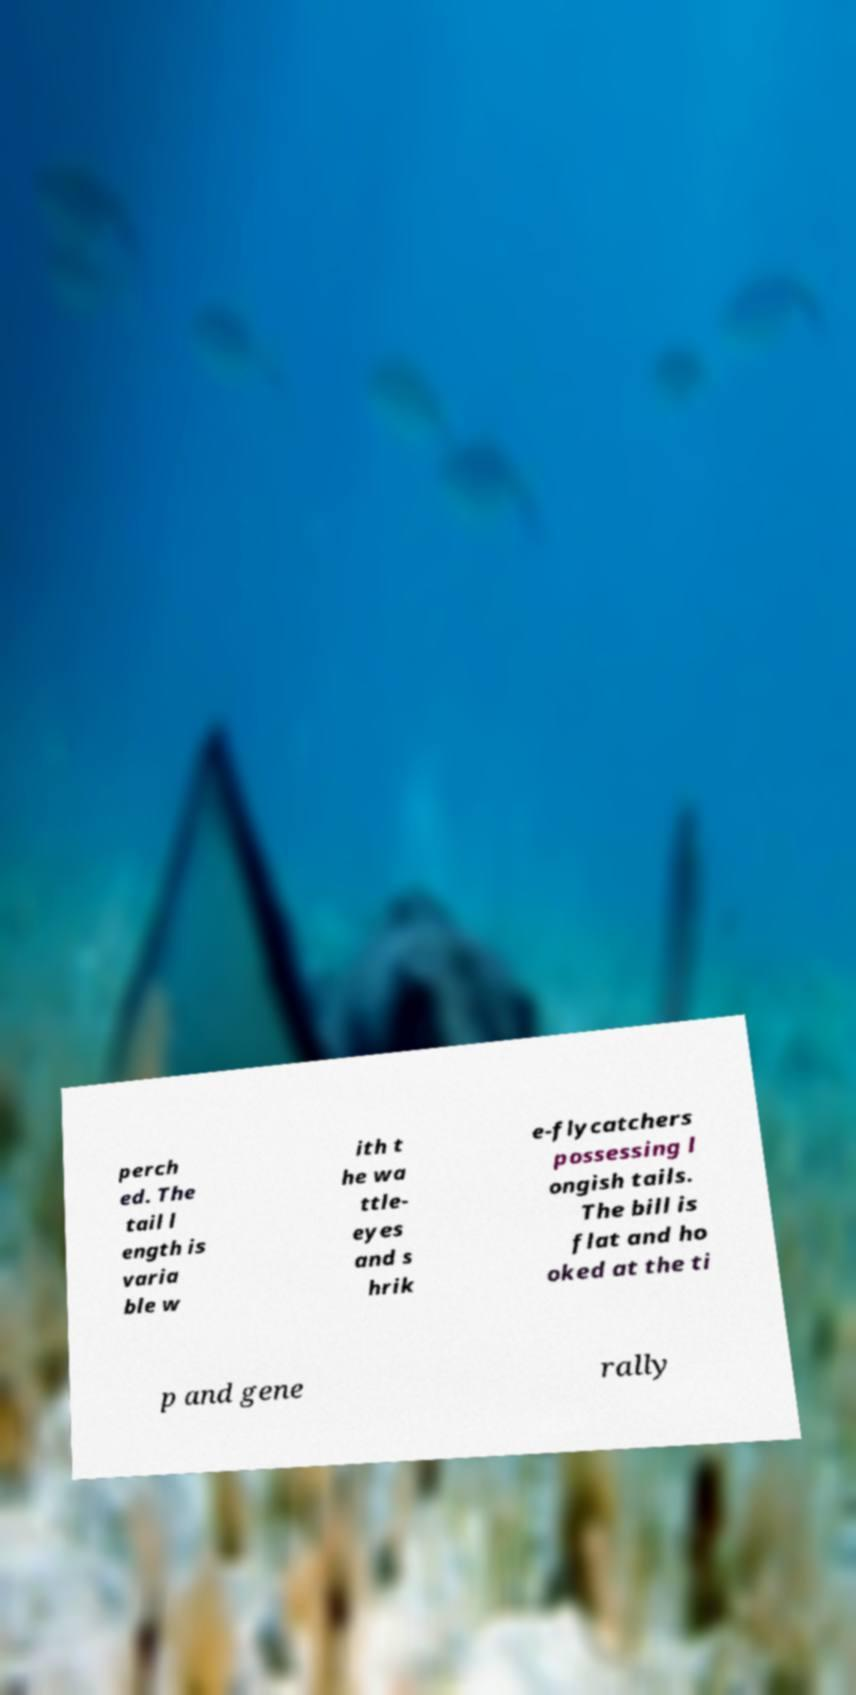For documentation purposes, I need the text within this image transcribed. Could you provide that? perch ed. The tail l ength is varia ble w ith t he wa ttle- eyes and s hrik e-flycatchers possessing l ongish tails. The bill is flat and ho oked at the ti p and gene rally 